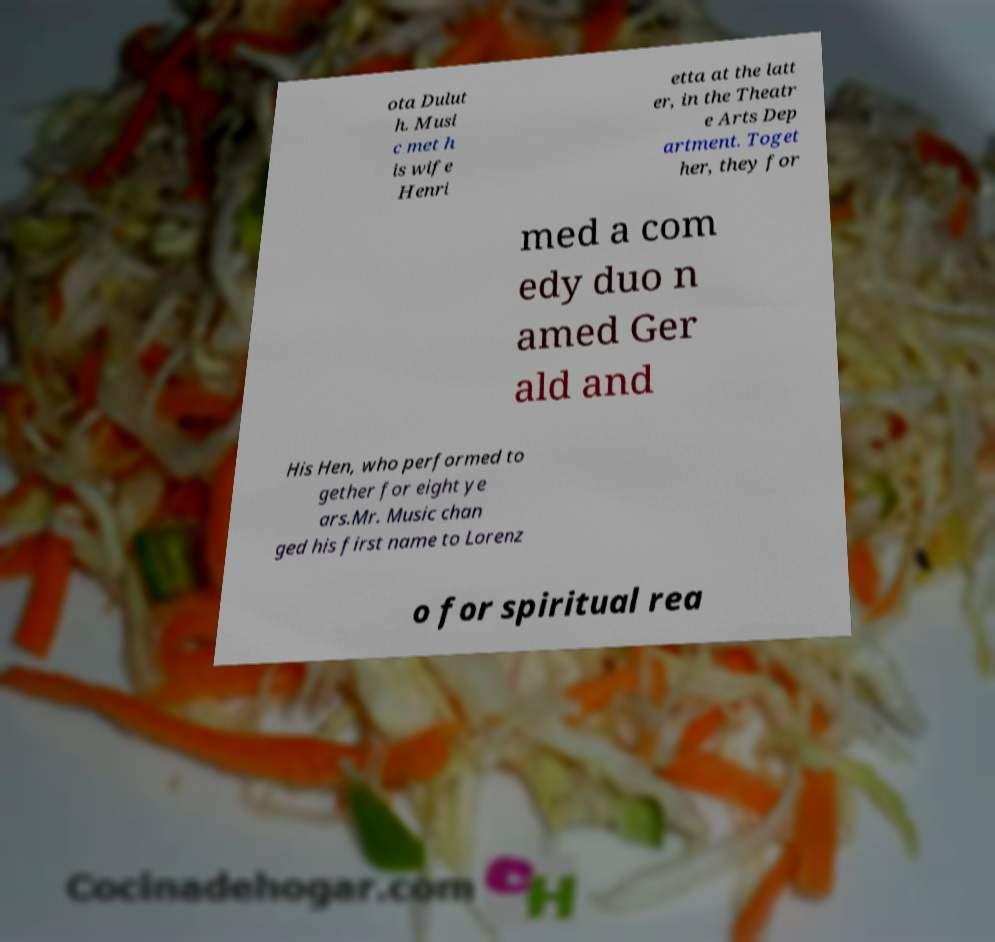What messages or text are displayed in this image? I need them in a readable, typed format. ota Dulut h. Musi c met h is wife Henri etta at the latt er, in the Theatr e Arts Dep artment. Toget her, they for med a com edy duo n amed Ger ald and His Hen, who performed to gether for eight ye ars.Mr. Music chan ged his first name to Lorenz o for spiritual rea 